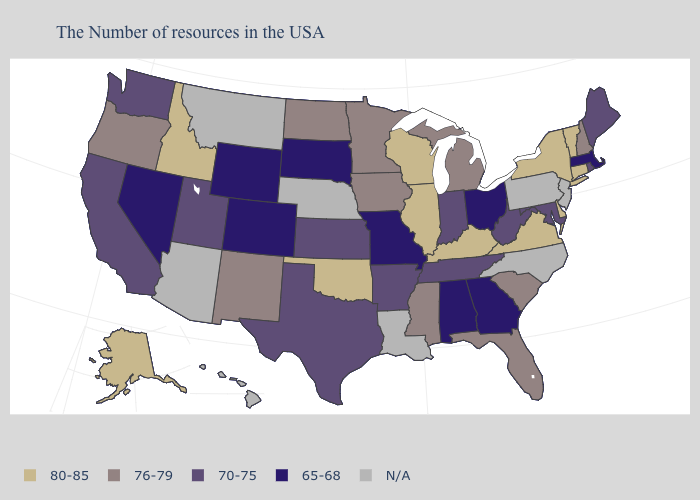What is the highest value in the South ?
Give a very brief answer. 80-85. Does the first symbol in the legend represent the smallest category?
Give a very brief answer. No. What is the value of South Dakota?
Quick response, please. 65-68. Which states have the lowest value in the USA?
Be succinct. Massachusetts, Ohio, Georgia, Alabama, Missouri, South Dakota, Wyoming, Colorado, Nevada. What is the value of West Virginia?
Give a very brief answer. 70-75. What is the highest value in states that border Kansas?
Give a very brief answer. 80-85. What is the value of Missouri?
Keep it brief. 65-68. Name the states that have a value in the range 76-79?
Quick response, please. New Hampshire, South Carolina, Florida, Michigan, Mississippi, Minnesota, Iowa, North Dakota, New Mexico, Oregon. What is the value of Arkansas?
Be succinct. 70-75. Is the legend a continuous bar?
Keep it brief. No. Does the first symbol in the legend represent the smallest category?
Answer briefly. No. Which states have the highest value in the USA?
Write a very short answer. Vermont, Connecticut, New York, Delaware, Virginia, Kentucky, Wisconsin, Illinois, Oklahoma, Idaho, Alaska. 